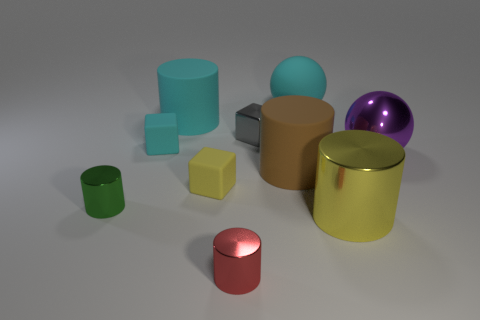What can you say about the sizes of the objects compared to each other? The objects vary in size, with the yellow cylinder being the largest, followed by the brown cylinder, with the red cylinder being the smallest one. The spherical objects and the cube range from medium to small compared to the rest. 